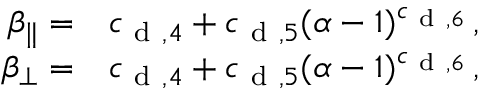Convert formula to latex. <formula><loc_0><loc_0><loc_500><loc_500>\begin{array} { r l } { \beta _ { \| } = } & c _ { d , 4 } + c _ { d , 5 } ( \alpha - 1 ) ^ { c _ { d , 6 } } \, , } \\ { \beta _ { \perp } = } & c _ { d , 4 } + c _ { d , 5 } ( \alpha - 1 ) ^ { c _ { d , 6 } } \, , } \end{array}</formula> 